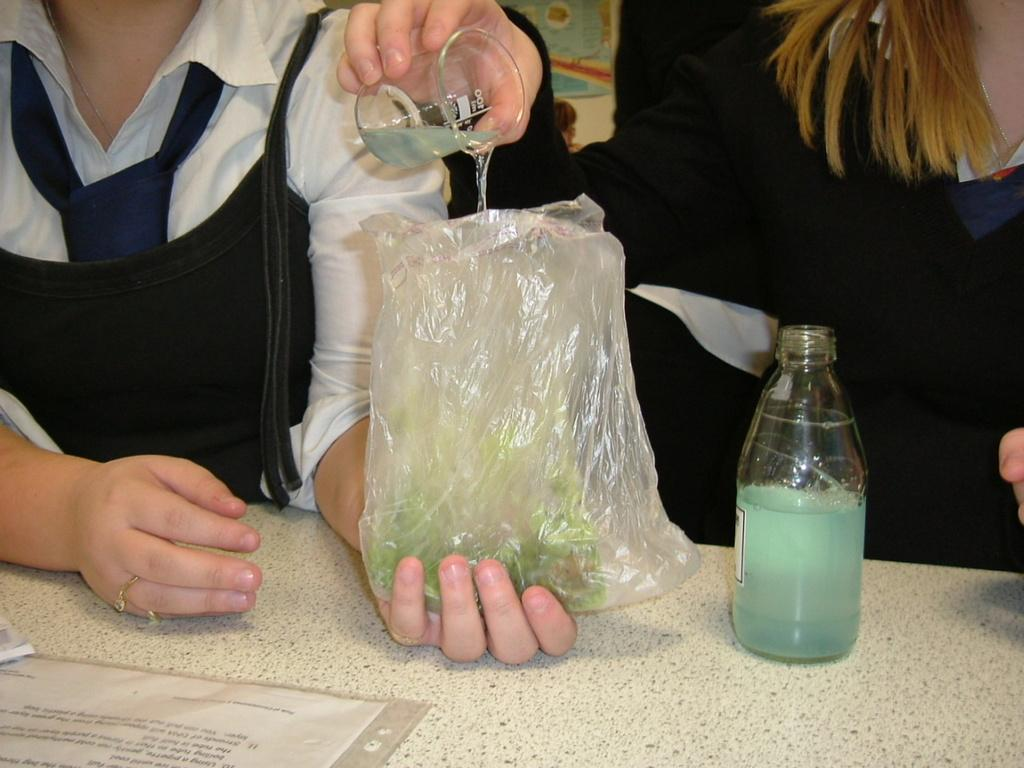Who is present in the image? There is a woman in the image. What is the woman doing in the image? The woman is pouring a chemical into a cover. What can be seen on the table in front of the woman? There is a table in front of the two women, and on it, there is a glass flask and a file. What type of doll is sitting on the table next to the glass flask? There is no doll present on the table next to the glass flask in the image. 